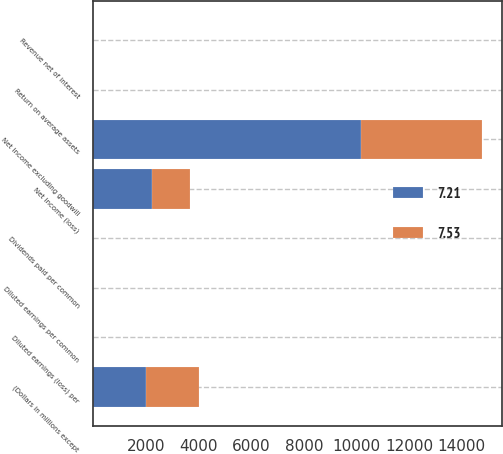Convert chart. <chart><loc_0><loc_0><loc_500><loc_500><stacked_bar_chart><ecel><fcel>(Dollars in millions except<fcel>Revenue net of interest<fcel>Net income (loss)<fcel>Net income excluding goodwill<fcel>Diluted earnings (loss) per<fcel>Diluted earnings per common<fcel>Dividends paid per common<fcel>Return on average assets<nl><fcel>7.53<fcel>2011<fcel>0.64<fcel>1446<fcel>4630<fcel>0.01<fcel>0.32<fcel>0.04<fcel>0.2<nl><fcel>7.21<fcel>2010<fcel>0.64<fcel>2238<fcel>10162<fcel>0.37<fcel>0.86<fcel>0.04<fcel>0.42<nl></chart> 